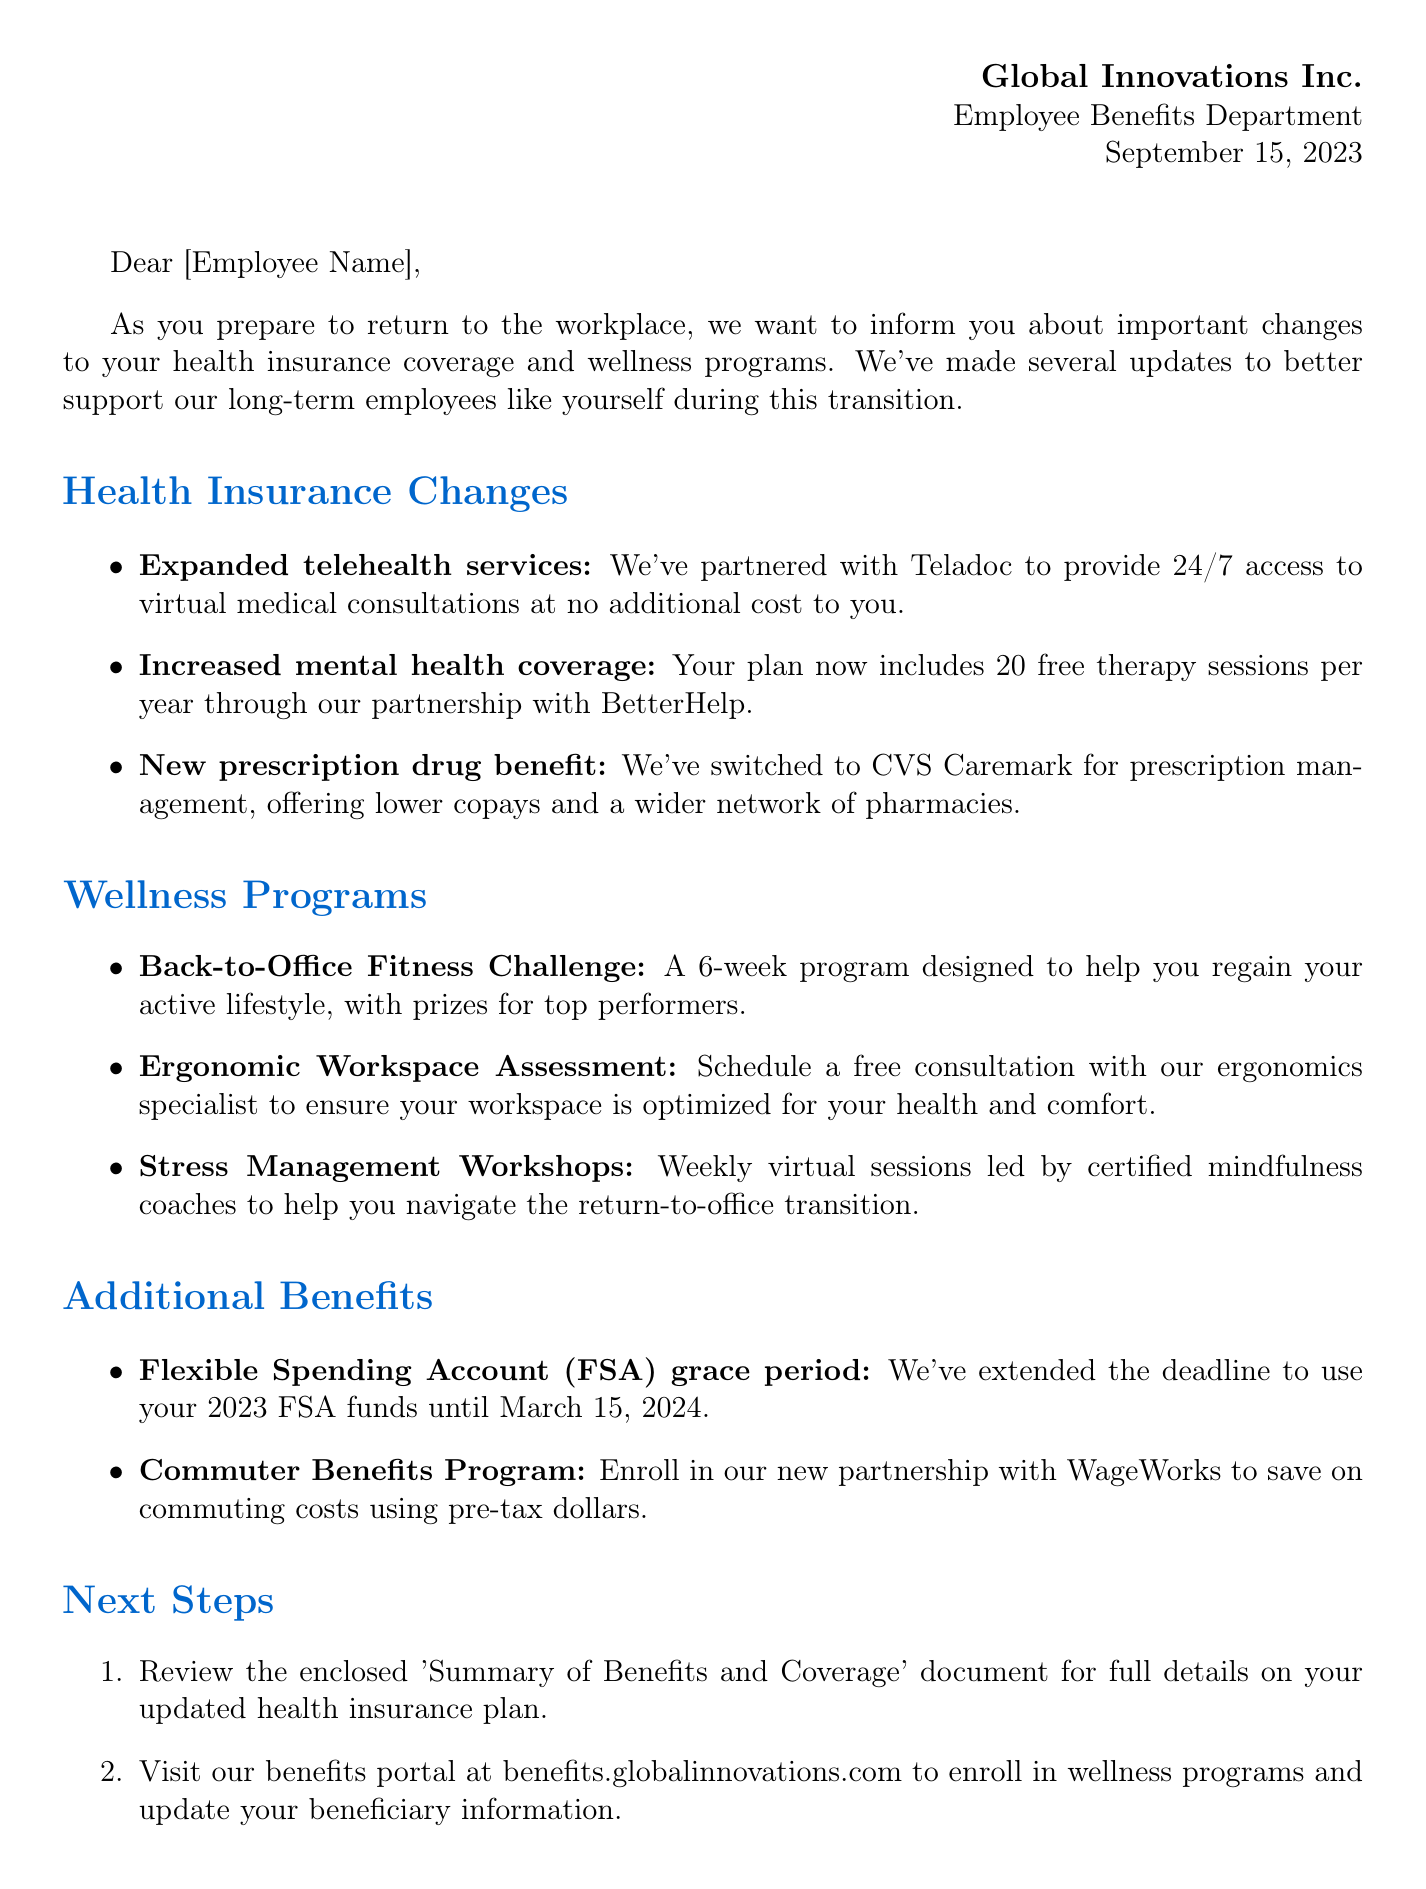What is the date of the letter? The date mentioned in the letter header is the most important date, which is September 15, 2023.
Answer: September 15, 2023 Who is the director of Employee Benefits? The signature section of the document includes the name and title of the person, which is Sarah Thompson.
Answer: Sarah Thompson What new benefit is provided for mental health coverage? The document states the increase in mental health coverage, which includes 20 free therapy sessions per year.
Answer: 20 free therapy sessions What is the program designed to help employees regain their active lifestyle? The letter describes a specific wellness program called the Back-to-Office Fitness Challenge.
Answer: Back-to-Office Fitness Challenge What is the deadline for using 2023 FSA funds? The additional benefits section states the extended deadline, which is March 15, 2024.
Answer: March 15, 2024 What online resource should employees visit to enroll in wellness programs? The next steps portion explicitly mentions the benefits portal link that employees should visit.
Answer: benefits.globalinnovations.com When is the virtual 'Welcome Back Benefits Orientation'? This specific event date is highlighted in the next steps section of the letter.
Answer: October 1, 2023 How many sessions are included in the Stress Management Workshops? The wellness program section mentions weekly sessions, providing a specific count per week.
Answer: Weekly sessions What is the new prescription management service provided? The letter specifies a new partnership for prescription management, which is CVS Caremark.
Answer: CVS Caremark 